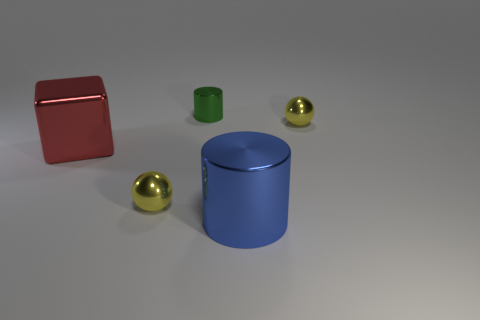How big is the cylinder behind the big red metallic thing?
Give a very brief answer. Small. Do the big metallic cylinder and the tiny ball that is on the left side of the big blue cylinder have the same color?
Give a very brief answer. No. Is there a small metal object that has the same color as the block?
Keep it short and to the point. No. Are the blue cylinder and the thing to the right of the large blue thing made of the same material?
Make the answer very short. Yes. What number of big objects are red objects or blue metal blocks?
Provide a succinct answer. 1. Are there fewer large purple balls than big red shiny blocks?
Keep it short and to the point. Yes. Is the size of the yellow shiny ball to the left of the small metal cylinder the same as the yellow metal sphere that is to the right of the green object?
Your answer should be compact. Yes. How many green objects are either cubes or shiny things?
Ensure brevity in your answer.  1. Is the number of large brown rubber objects greater than the number of large blue things?
Offer a very short reply. No. Do the big cylinder and the block have the same color?
Your answer should be compact. No. 